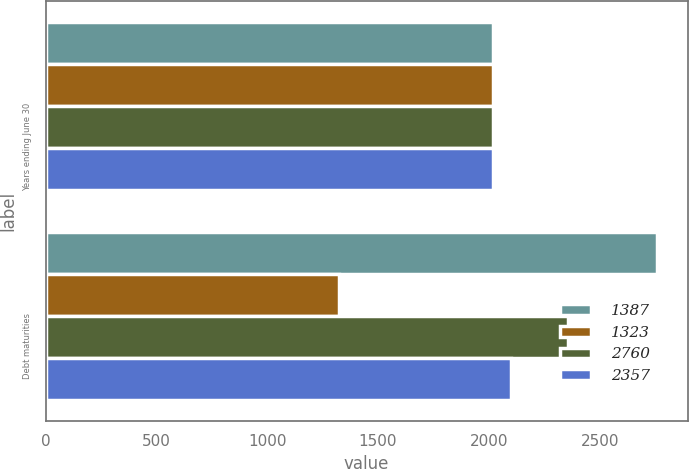Convert chart to OTSL. <chart><loc_0><loc_0><loc_500><loc_500><stacked_bar_chart><ecel><fcel>Years ending June 30<fcel>Debt maturities<nl><fcel>1387<fcel>2017<fcel>2760<nl><fcel>1323<fcel>2018<fcel>1323<nl><fcel>2760<fcel>2019<fcel>2357<nl><fcel>2357<fcel>2020<fcel>2099<nl></chart> 